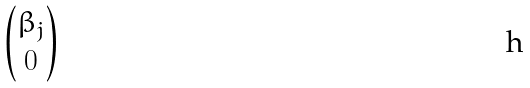Convert formula to latex. <formula><loc_0><loc_0><loc_500><loc_500>\begin{pmatrix} \beta _ { j } \\ 0 \end{pmatrix}</formula> 